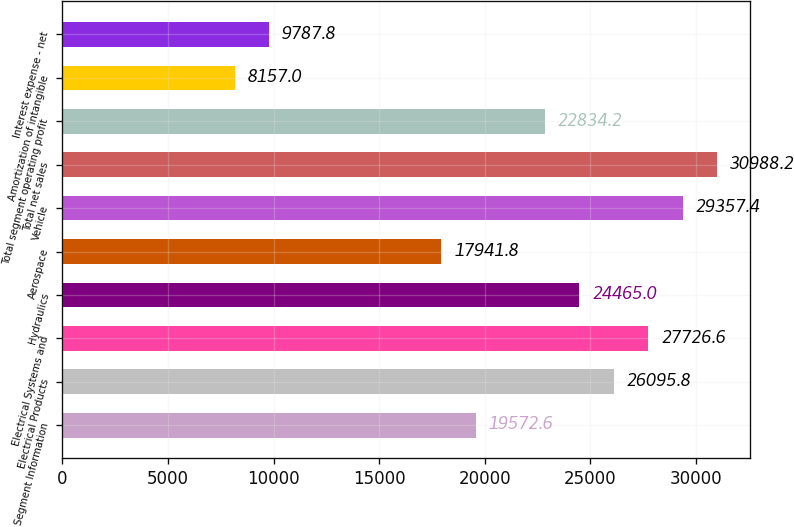<chart> <loc_0><loc_0><loc_500><loc_500><bar_chart><fcel>Business Segment Information<fcel>Electrical Products<fcel>Electrical Systems and<fcel>Hydraulics<fcel>Aerospace<fcel>Vehicle<fcel>Total net sales<fcel>Total segment operating profit<fcel>Amortization of intangible<fcel>Interest expense - net<nl><fcel>19572.6<fcel>26095.8<fcel>27726.6<fcel>24465<fcel>17941.8<fcel>29357.4<fcel>30988.2<fcel>22834.2<fcel>8157<fcel>9787.8<nl></chart> 